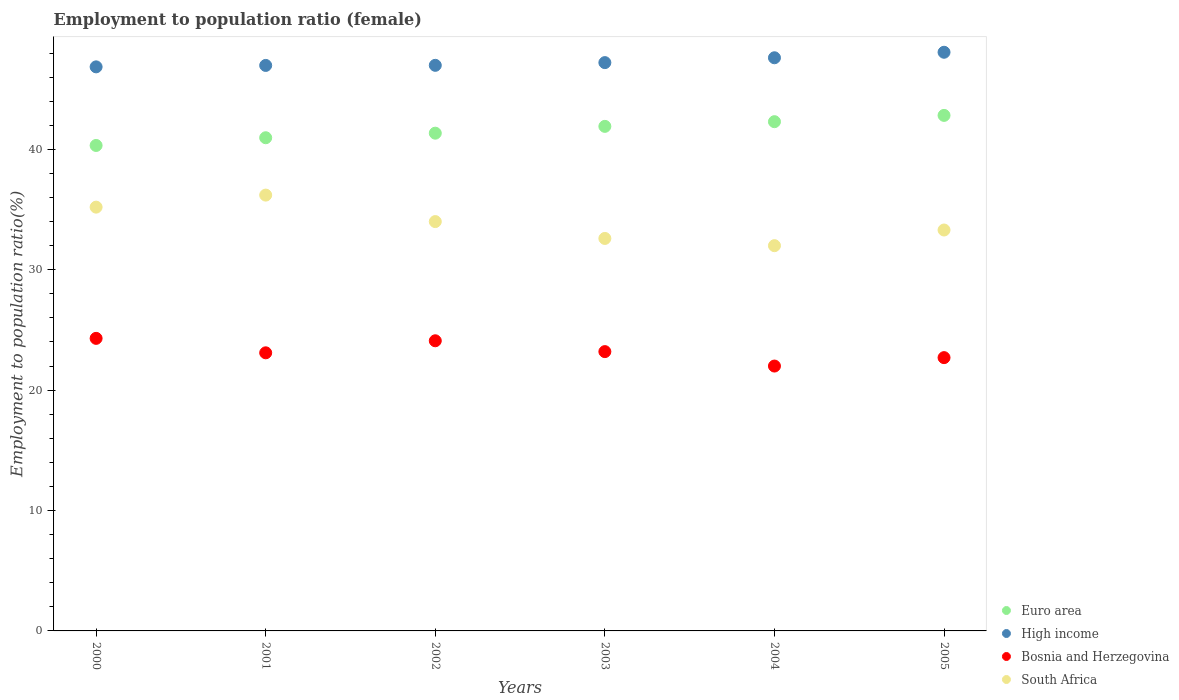What is the employment to population ratio in High income in 2005?
Provide a short and direct response. 48.06. Across all years, what is the maximum employment to population ratio in Bosnia and Herzegovina?
Keep it short and to the point. 24.3. In which year was the employment to population ratio in Euro area maximum?
Offer a very short reply. 2005. What is the total employment to population ratio in Euro area in the graph?
Give a very brief answer. 249.66. What is the difference between the employment to population ratio in Euro area in 2002 and that in 2003?
Keep it short and to the point. -0.57. What is the difference between the employment to population ratio in High income in 2004 and the employment to population ratio in South Africa in 2001?
Make the answer very short. 11.41. What is the average employment to population ratio in High income per year?
Your response must be concise. 47.28. In the year 2002, what is the difference between the employment to population ratio in South Africa and employment to population ratio in Bosnia and Herzegovina?
Give a very brief answer. 9.9. In how many years, is the employment to population ratio in Euro area greater than 4 %?
Provide a short and direct response. 6. What is the ratio of the employment to population ratio in High income in 2000 to that in 2003?
Offer a very short reply. 0.99. Is the employment to population ratio in High income in 2002 less than that in 2004?
Provide a short and direct response. Yes. What is the difference between the highest and the lowest employment to population ratio in Bosnia and Herzegovina?
Offer a terse response. 2.3. In how many years, is the employment to population ratio in High income greater than the average employment to population ratio in High income taken over all years?
Ensure brevity in your answer.  2. Is the sum of the employment to population ratio in South Africa in 2004 and 2005 greater than the maximum employment to population ratio in High income across all years?
Ensure brevity in your answer.  Yes. Is it the case that in every year, the sum of the employment to population ratio in Euro area and employment to population ratio in Bosnia and Herzegovina  is greater than the sum of employment to population ratio in South Africa and employment to population ratio in High income?
Your answer should be compact. Yes. Does the employment to population ratio in Euro area monotonically increase over the years?
Make the answer very short. Yes. Is the employment to population ratio in Euro area strictly greater than the employment to population ratio in South Africa over the years?
Give a very brief answer. Yes. Is the employment to population ratio in High income strictly less than the employment to population ratio in South Africa over the years?
Provide a short and direct response. No. Does the graph contain grids?
Provide a succinct answer. No. How many legend labels are there?
Provide a succinct answer. 4. What is the title of the graph?
Make the answer very short. Employment to population ratio (female). What is the label or title of the Y-axis?
Provide a short and direct response. Employment to population ratio(%). What is the Employment to population ratio(%) of Euro area in 2000?
Offer a terse response. 40.32. What is the Employment to population ratio(%) in High income in 2000?
Your answer should be very brief. 46.85. What is the Employment to population ratio(%) in Bosnia and Herzegovina in 2000?
Offer a very short reply. 24.3. What is the Employment to population ratio(%) in South Africa in 2000?
Provide a short and direct response. 35.2. What is the Employment to population ratio(%) of Euro area in 2001?
Provide a succinct answer. 40.96. What is the Employment to population ratio(%) in High income in 2001?
Make the answer very short. 46.97. What is the Employment to population ratio(%) in Bosnia and Herzegovina in 2001?
Make the answer very short. 23.1. What is the Employment to population ratio(%) of South Africa in 2001?
Give a very brief answer. 36.2. What is the Employment to population ratio(%) in Euro area in 2002?
Your answer should be very brief. 41.34. What is the Employment to population ratio(%) in High income in 2002?
Keep it short and to the point. 46.98. What is the Employment to population ratio(%) in Bosnia and Herzegovina in 2002?
Offer a very short reply. 24.1. What is the Employment to population ratio(%) in Euro area in 2003?
Keep it short and to the point. 41.91. What is the Employment to population ratio(%) in High income in 2003?
Keep it short and to the point. 47.2. What is the Employment to population ratio(%) in Bosnia and Herzegovina in 2003?
Your answer should be compact. 23.2. What is the Employment to population ratio(%) in South Africa in 2003?
Provide a succinct answer. 32.6. What is the Employment to population ratio(%) of Euro area in 2004?
Your answer should be very brief. 42.3. What is the Employment to population ratio(%) of High income in 2004?
Your response must be concise. 47.61. What is the Employment to population ratio(%) of South Africa in 2004?
Your answer should be compact. 32. What is the Employment to population ratio(%) of Euro area in 2005?
Make the answer very short. 42.82. What is the Employment to population ratio(%) of High income in 2005?
Offer a very short reply. 48.06. What is the Employment to population ratio(%) of Bosnia and Herzegovina in 2005?
Your answer should be compact. 22.7. What is the Employment to population ratio(%) of South Africa in 2005?
Keep it short and to the point. 33.3. Across all years, what is the maximum Employment to population ratio(%) of Euro area?
Make the answer very short. 42.82. Across all years, what is the maximum Employment to population ratio(%) in High income?
Your answer should be very brief. 48.06. Across all years, what is the maximum Employment to population ratio(%) in Bosnia and Herzegovina?
Provide a short and direct response. 24.3. Across all years, what is the maximum Employment to population ratio(%) in South Africa?
Ensure brevity in your answer.  36.2. Across all years, what is the minimum Employment to population ratio(%) of Euro area?
Your answer should be compact. 40.32. Across all years, what is the minimum Employment to population ratio(%) of High income?
Keep it short and to the point. 46.85. Across all years, what is the minimum Employment to population ratio(%) of Bosnia and Herzegovina?
Provide a succinct answer. 22. What is the total Employment to population ratio(%) in Euro area in the graph?
Offer a terse response. 249.66. What is the total Employment to population ratio(%) of High income in the graph?
Your answer should be very brief. 283.68. What is the total Employment to population ratio(%) in Bosnia and Herzegovina in the graph?
Provide a short and direct response. 139.4. What is the total Employment to population ratio(%) of South Africa in the graph?
Keep it short and to the point. 203.3. What is the difference between the Employment to population ratio(%) in Euro area in 2000 and that in 2001?
Provide a short and direct response. -0.64. What is the difference between the Employment to population ratio(%) in High income in 2000 and that in 2001?
Offer a very short reply. -0.12. What is the difference between the Employment to population ratio(%) in Bosnia and Herzegovina in 2000 and that in 2001?
Your response must be concise. 1.2. What is the difference between the Employment to population ratio(%) of South Africa in 2000 and that in 2001?
Your response must be concise. -1. What is the difference between the Employment to population ratio(%) in Euro area in 2000 and that in 2002?
Keep it short and to the point. -1.02. What is the difference between the Employment to population ratio(%) of High income in 2000 and that in 2002?
Keep it short and to the point. -0.13. What is the difference between the Employment to population ratio(%) in Bosnia and Herzegovina in 2000 and that in 2002?
Your response must be concise. 0.2. What is the difference between the Employment to population ratio(%) of Euro area in 2000 and that in 2003?
Keep it short and to the point. -1.59. What is the difference between the Employment to population ratio(%) in High income in 2000 and that in 2003?
Offer a terse response. -0.35. What is the difference between the Employment to population ratio(%) of South Africa in 2000 and that in 2003?
Your response must be concise. 2.6. What is the difference between the Employment to population ratio(%) of Euro area in 2000 and that in 2004?
Keep it short and to the point. -1.98. What is the difference between the Employment to population ratio(%) in High income in 2000 and that in 2004?
Ensure brevity in your answer.  -0.76. What is the difference between the Employment to population ratio(%) of Bosnia and Herzegovina in 2000 and that in 2004?
Offer a very short reply. 2.3. What is the difference between the Employment to population ratio(%) of Euro area in 2000 and that in 2005?
Keep it short and to the point. -2.5. What is the difference between the Employment to population ratio(%) in High income in 2000 and that in 2005?
Make the answer very short. -1.21. What is the difference between the Employment to population ratio(%) of South Africa in 2000 and that in 2005?
Give a very brief answer. 1.9. What is the difference between the Employment to population ratio(%) of Euro area in 2001 and that in 2002?
Offer a very short reply. -0.38. What is the difference between the Employment to population ratio(%) of High income in 2001 and that in 2002?
Your answer should be compact. -0.01. What is the difference between the Employment to population ratio(%) of South Africa in 2001 and that in 2002?
Your answer should be very brief. 2.2. What is the difference between the Employment to population ratio(%) in Euro area in 2001 and that in 2003?
Offer a very short reply. -0.94. What is the difference between the Employment to population ratio(%) of High income in 2001 and that in 2003?
Make the answer very short. -0.23. What is the difference between the Employment to population ratio(%) of Bosnia and Herzegovina in 2001 and that in 2003?
Provide a succinct answer. -0.1. What is the difference between the Employment to population ratio(%) in Euro area in 2001 and that in 2004?
Provide a succinct answer. -1.33. What is the difference between the Employment to population ratio(%) of High income in 2001 and that in 2004?
Offer a terse response. -0.64. What is the difference between the Employment to population ratio(%) in South Africa in 2001 and that in 2004?
Provide a succinct answer. 4.2. What is the difference between the Employment to population ratio(%) in Euro area in 2001 and that in 2005?
Your response must be concise. -1.86. What is the difference between the Employment to population ratio(%) in High income in 2001 and that in 2005?
Provide a short and direct response. -1.09. What is the difference between the Employment to population ratio(%) of Bosnia and Herzegovina in 2001 and that in 2005?
Your response must be concise. 0.4. What is the difference between the Employment to population ratio(%) of South Africa in 2001 and that in 2005?
Your answer should be compact. 2.9. What is the difference between the Employment to population ratio(%) in Euro area in 2002 and that in 2003?
Make the answer very short. -0.57. What is the difference between the Employment to population ratio(%) of High income in 2002 and that in 2003?
Make the answer very short. -0.23. What is the difference between the Employment to population ratio(%) of Bosnia and Herzegovina in 2002 and that in 2003?
Your answer should be compact. 0.9. What is the difference between the Employment to population ratio(%) in Euro area in 2002 and that in 2004?
Keep it short and to the point. -0.95. What is the difference between the Employment to population ratio(%) of High income in 2002 and that in 2004?
Your answer should be compact. -0.63. What is the difference between the Employment to population ratio(%) of Euro area in 2002 and that in 2005?
Give a very brief answer. -1.48. What is the difference between the Employment to population ratio(%) in High income in 2002 and that in 2005?
Keep it short and to the point. -1.09. What is the difference between the Employment to population ratio(%) of South Africa in 2002 and that in 2005?
Make the answer very short. 0.7. What is the difference between the Employment to population ratio(%) in Euro area in 2003 and that in 2004?
Ensure brevity in your answer.  -0.39. What is the difference between the Employment to population ratio(%) in High income in 2003 and that in 2004?
Ensure brevity in your answer.  -0.4. What is the difference between the Employment to population ratio(%) in South Africa in 2003 and that in 2004?
Make the answer very short. 0.6. What is the difference between the Employment to population ratio(%) of Euro area in 2003 and that in 2005?
Keep it short and to the point. -0.91. What is the difference between the Employment to population ratio(%) in High income in 2003 and that in 2005?
Your answer should be very brief. -0.86. What is the difference between the Employment to population ratio(%) in Bosnia and Herzegovina in 2003 and that in 2005?
Provide a succinct answer. 0.5. What is the difference between the Employment to population ratio(%) in Euro area in 2004 and that in 2005?
Offer a very short reply. -0.52. What is the difference between the Employment to population ratio(%) in High income in 2004 and that in 2005?
Your answer should be compact. -0.46. What is the difference between the Employment to population ratio(%) in Bosnia and Herzegovina in 2004 and that in 2005?
Keep it short and to the point. -0.7. What is the difference between the Employment to population ratio(%) of Euro area in 2000 and the Employment to population ratio(%) of High income in 2001?
Give a very brief answer. -6.65. What is the difference between the Employment to population ratio(%) in Euro area in 2000 and the Employment to population ratio(%) in Bosnia and Herzegovina in 2001?
Keep it short and to the point. 17.22. What is the difference between the Employment to population ratio(%) in Euro area in 2000 and the Employment to population ratio(%) in South Africa in 2001?
Your answer should be compact. 4.12. What is the difference between the Employment to population ratio(%) of High income in 2000 and the Employment to population ratio(%) of Bosnia and Herzegovina in 2001?
Your response must be concise. 23.75. What is the difference between the Employment to population ratio(%) of High income in 2000 and the Employment to population ratio(%) of South Africa in 2001?
Your answer should be compact. 10.65. What is the difference between the Employment to population ratio(%) of Bosnia and Herzegovina in 2000 and the Employment to population ratio(%) of South Africa in 2001?
Give a very brief answer. -11.9. What is the difference between the Employment to population ratio(%) of Euro area in 2000 and the Employment to population ratio(%) of High income in 2002?
Ensure brevity in your answer.  -6.66. What is the difference between the Employment to population ratio(%) of Euro area in 2000 and the Employment to population ratio(%) of Bosnia and Herzegovina in 2002?
Make the answer very short. 16.22. What is the difference between the Employment to population ratio(%) of Euro area in 2000 and the Employment to population ratio(%) of South Africa in 2002?
Give a very brief answer. 6.32. What is the difference between the Employment to population ratio(%) in High income in 2000 and the Employment to population ratio(%) in Bosnia and Herzegovina in 2002?
Ensure brevity in your answer.  22.75. What is the difference between the Employment to population ratio(%) of High income in 2000 and the Employment to population ratio(%) of South Africa in 2002?
Keep it short and to the point. 12.85. What is the difference between the Employment to population ratio(%) of Euro area in 2000 and the Employment to population ratio(%) of High income in 2003?
Offer a terse response. -6.88. What is the difference between the Employment to population ratio(%) in Euro area in 2000 and the Employment to population ratio(%) in Bosnia and Herzegovina in 2003?
Ensure brevity in your answer.  17.12. What is the difference between the Employment to population ratio(%) in Euro area in 2000 and the Employment to population ratio(%) in South Africa in 2003?
Provide a succinct answer. 7.72. What is the difference between the Employment to population ratio(%) in High income in 2000 and the Employment to population ratio(%) in Bosnia and Herzegovina in 2003?
Keep it short and to the point. 23.65. What is the difference between the Employment to population ratio(%) of High income in 2000 and the Employment to population ratio(%) of South Africa in 2003?
Offer a terse response. 14.25. What is the difference between the Employment to population ratio(%) of Bosnia and Herzegovina in 2000 and the Employment to population ratio(%) of South Africa in 2003?
Give a very brief answer. -8.3. What is the difference between the Employment to population ratio(%) in Euro area in 2000 and the Employment to population ratio(%) in High income in 2004?
Offer a terse response. -7.28. What is the difference between the Employment to population ratio(%) in Euro area in 2000 and the Employment to population ratio(%) in Bosnia and Herzegovina in 2004?
Offer a terse response. 18.32. What is the difference between the Employment to population ratio(%) in Euro area in 2000 and the Employment to population ratio(%) in South Africa in 2004?
Ensure brevity in your answer.  8.32. What is the difference between the Employment to population ratio(%) of High income in 2000 and the Employment to population ratio(%) of Bosnia and Herzegovina in 2004?
Provide a succinct answer. 24.85. What is the difference between the Employment to population ratio(%) of High income in 2000 and the Employment to population ratio(%) of South Africa in 2004?
Ensure brevity in your answer.  14.85. What is the difference between the Employment to population ratio(%) of Bosnia and Herzegovina in 2000 and the Employment to population ratio(%) of South Africa in 2004?
Your answer should be very brief. -7.7. What is the difference between the Employment to population ratio(%) of Euro area in 2000 and the Employment to population ratio(%) of High income in 2005?
Your response must be concise. -7.74. What is the difference between the Employment to population ratio(%) of Euro area in 2000 and the Employment to population ratio(%) of Bosnia and Herzegovina in 2005?
Offer a terse response. 17.62. What is the difference between the Employment to population ratio(%) of Euro area in 2000 and the Employment to population ratio(%) of South Africa in 2005?
Provide a short and direct response. 7.02. What is the difference between the Employment to population ratio(%) in High income in 2000 and the Employment to population ratio(%) in Bosnia and Herzegovina in 2005?
Your response must be concise. 24.15. What is the difference between the Employment to population ratio(%) in High income in 2000 and the Employment to population ratio(%) in South Africa in 2005?
Provide a succinct answer. 13.55. What is the difference between the Employment to population ratio(%) in Euro area in 2001 and the Employment to population ratio(%) in High income in 2002?
Offer a terse response. -6.01. What is the difference between the Employment to population ratio(%) in Euro area in 2001 and the Employment to population ratio(%) in Bosnia and Herzegovina in 2002?
Offer a very short reply. 16.86. What is the difference between the Employment to population ratio(%) of Euro area in 2001 and the Employment to population ratio(%) of South Africa in 2002?
Your answer should be compact. 6.96. What is the difference between the Employment to population ratio(%) in High income in 2001 and the Employment to population ratio(%) in Bosnia and Herzegovina in 2002?
Offer a very short reply. 22.87. What is the difference between the Employment to population ratio(%) in High income in 2001 and the Employment to population ratio(%) in South Africa in 2002?
Offer a very short reply. 12.97. What is the difference between the Employment to population ratio(%) of Euro area in 2001 and the Employment to population ratio(%) of High income in 2003?
Offer a terse response. -6.24. What is the difference between the Employment to population ratio(%) of Euro area in 2001 and the Employment to population ratio(%) of Bosnia and Herzegovina in 2003?
Keep it short and to the point. 17.76. What is the difference between the Employment to population ratio(%) in Euro area in 2001 and the Employment to population ratio(%) in South Africa in 2003?
Your answer should be compact. 8.36. What is the difference between the Employment to population ratio(%) of High income in 2001 and the Employment to population ratio(%) of Bosnia and Herzegovina in 2003?
Offer a terse response. 23.77. What is the difference between the Employment to population ratio(%) of High income in 2001 and the Employment to population ratio(%) of South Africa in 2003?
Give a very brief answer. 14.37. What is the difference between the Employment to population ratio(%) in Bosnia and Herzegovina in 2001 and the Employment to population ratio(%) in South Africa in 2003?
Ensure brevity in your answer.  -9.5. What is the difference between the Employment to population ratio(%) in Euro area in 2001 and the Employment to population ratio(%) in High income in 2004?
Offer a terse response. -6.64. What is the difference between the Employment to population ratio(%) in Euro area in 2001 and the Employment to population ratio(%) in Bosnia and Herzegovina in 2004?
Offer a very short reply. 18.96. What is the difference between the Employment to population ratio(%) in Euro area in 2001 and the Employment to population ratio(%) in South Africa in 2004?
Your response must be concise. 8.96. What is the difference between the Employment to population ratio(%) in High income in 2001 and the Employment to population ratio(%) in Bosnia and Herzegovina in 2004?
Your response must be concise. 24.97. What is the difference between the Employment to population ratio(%) in High income in 2001 and the Employment to population ratio(%) in South Africa in 2004?
Provide a succinct answer. 14.97. What is the difference between the Employment to population ratio(%) in Euro area in 2001 and the Employment to population ratio(%) in High income in 2005?
Provide a short and direct response. -7.1. What is the difference between the Employment to population ratio(%) in Euro area in 2001 and the Employment to population ratio(%) in Bosnia and Herzegovina in 2005?
Keep it short and to the point. 18.26. What is the difference between the Employment to population ratio(%) of Euro area in 2001 and the Employment to population ratio(%) of South Africa in 2005?
Ensure brevity in your answer.  7.66. What is the difference between the Employment to population ratio(%) in High income in 2001 and the Employment to population ratio(%) in Bosnia and Herzegovina in 2005?
Provide a succinct answer. 24.27. What is the difference between the Employment to population ratio(%) in High income in 2001 and the Employment to population ratio(%) in South Africa in 2005?
Give a very brief answer. 13.67. What is the difference between the Employment to population ratio(%) of Euro area in 2002 and the Employment to population ratio(%) of High income in 2003?
Give a very brief answer. -5.86. What is the difference between the Employment to population ratio(%) of Euro area in 2002 and the Employment to population ratio(%) of Bosnia and Herzegovina in 2003?
Offer a terse response. 18.14. What is the difference between the Employment to population ratio(%) in Euro area in 2002 and the Employment to population ratio(%) in South Africa in 2003?
Your answer should be very brief. 8.74. What is the difference between the Employment to population ratio(%) of High income in 2002 and the Employment to population ratio(%) of Bosnia and Herzegovina in 2003?
Your response must be concise. 23.78. What is the difference between the Employment to population ratio(%) of High income in 2002 and the Employment to population ratio(%) of South Africa in 2003?
Your response must be concise. 14.38. What is the difference between the Employment to population ratio(%) of Bosnia and Herzegovina in 2002 and the Employment to population ratio(%) of South Africa in 2003?
Your answer should be compact. -8.5. What is the difference between the Employment to population ratio(%) of Euro area in 2002 and the Employment to population ratio(%) of High income in 2004?
Your answer should be very brief. -6.26. What is the difference between the Employment to population ratio(%) in Euro area in 2002 and the Employment to population ratio(%) in Bosnia and Herzegovina in 2004?
Offer a very short reply. 19.34. What is the difference between the Employment to population ratio(%) of Euro area in 2002 and the Employment to population ratio(%) of South Africa in 2004?
Keep it short and to the point. 9.34. What is the difference between the Employment to population ratio(%) of High income in 2002 and the Employment to population ratio(%) of Bosnia and Herzegovina in 2004?
Your answer should be very brief. 24.98. What is the difference between the Employment to population ratio(%) of High income in 2002 and the Employment to population ratio(%) of South Africa in 2004?
Provide a short and direct response. 14.98. What is the difference between the Employment to population ratio(%) of Bosnia and Herzegovina in 2002 and the Employment to population ratio(%) of South Africa in 2004?
Your response must be concise. -7.9. What is the difference between the Employment to population ratio(%) in Euro area in 2002 and the Employment to population ratio(%) in High income in 2005?
Provide a short and direct response. -6.72. What is the difference between the Employment to population ratio(%) in Euro area in 2002 and the Employment to population ratio(%) in Bosnia and Herzegovina in 2005?
Offer a very short reply. 18.64. What is the difference between the Employment to population ratio(%) in Euro area in 2002 and the Employment to population ratio(%) in South Africa in 2005?
Your response must be concise. 8.04. What is the difference between the Employment to population ratio(%) of High income in 2002 and the Employment to population ratio(%) of Bosnia and Herzegovina in 2005?
Your answer should be very brief. 24.28. What is the difference between the Employment to population ratio(%) in High income in 2002 and the Employment to population ratio(%) in South Africa in 2005?
Ensure brevity in your answer.  13.68. What is the difference between the Employment to population ratio(%) in Bosnia and Herzegovina in 2002 and the Employment to population ratio(%) in South Africa in 2005?
Keep it short and to the point. -9.2. What is the difference between the Employment to population ratio(%) in Euro area in 2003 and the Employment to population ratio(%) in High income in 2004?
Provide a succinct answer. -5.7. What is the difference between the Employment to population ratio(%) of Euro area in 2003 and the Employment to population ratio(%) of Bosnia and Herzegovina in 2004?
Your answer should be compact. 19.91. What is the difference between the Employment to population ratio(%) in Euro area in 2003 and the Employment to population ratio(%) in South Africa in 2004?
Make the answer very short. 9.91. What is the difference between the Employment to population ratio(%) in High income in 2003 and the Employment to population ratio(%) in Bosnia and Herzegovina in 2004?
Your answer should be very brief. 25.2. What is the difference between the Employment to population ratio(%) in High income in 2003 and the Employment to population ratio(%) in South Africa in 2004?
Your response must be concise. 15.2. What is the difference between the Employment to population ratio(%) of Euro area in 2003 and the Employment to population ratio(%) of High income in 2005?
Your response must be concise. -6.16. What is the difference between the Employment to population ratio(%) of Euro area in 2003 and the Employment to population ratio(%) of Bosnia and Herzegovina in 2005?
Your answer should be very brief. 19.21. What is the difference between the Employment to population ratio(%) in Euro area in 2003 and the Employment to population ratio(%) in South Africa in 2005?
Make the answer very short. 8.61. What is the difference between the Employment to population ratio(%) in High income in 2003 and the Employment to population ratio(%) in Bosnia and Herzegovina in 2005?
Make the answer very short. 24.5. What is the difference between the Employment to population ratio(%) of High income in 2003 and the Employment to population ratio(%) of South Africa in 2005?
Offer a very short reply. 13.9. What is the difference between the Employment to population ratio(%) of Euro area in 2004 and the Employment to population ratio(%) of High income in 2005?
Provide a short and direct response. -5.77. What is the difference between the Employment to population ratio(%) in Euro area in 2004 and the Employment to population ratio(%) in Bosnia and Herzegovina in 2005?
Ensure brevity in your answer.  19.6. What is the difference between the Employment to population ratio(%) in Euro area in 2004 and the Employment to population ratio(%) in South Africa in 2005?
Make the answer very short. 9. What is the difference between the Employment to population ratio(%) of High income in 2004 and the Employment to population ratio(%) of Bosnia and Herzegovina in 2005?
Ensure brevity in your answer.  24.91. What is the difference between the Employment to population ratio(%) in High income in 2004 and the Employment to population ratio(%) in South Africa in 2005?
Ensure brevity in your answer.  14.31. What is the average Employment to population ratio(%) in Euro area per year?
Provide a short and direct response. 41.61. What is the average Employment to population ratio(%) of High income per year?
Your answer should be very brief. 47.28. What is the average Employment to population ratio(%) of Bosnia and Herzegovina per year?
Keep it short and to the point. 23.23. What is the average Employment to population ratio(%) of South Africa per year?
Offer a terse response. 33.88. In the year 2000, what is the difference between the Employment to population ratio(%) of Euro area and Employment to population ratio(%) of High income?
Keep it short and to the point. -6.53. In the year 2000, what is the difference between the Employment to population ratio(%) of Euro area and Employment to population ratio(%) of Bosnia and Herzegovina?
Give a very brief answer. 16.02. In the year 2000, what is the difference between the Employment to population ratio(%) of Euro area and Employment to population ratio(%) of South Africa?
Ensure brevity in your answer.  5.12. In the year 2000, what is the difference between the Employment to population ratio(%) in High income and Employment to population ratio(%) in Bosnia and Herzegovina?
Make the answer very short. 22.55. In the year 2000, what is the difference between the Employment to population ratio(%) of High income and Employment to population ratio(%) of South Africa?
Ensure brevity in your answer.  11.65. In the year 2001, what is the difference between the Employment to population ratio(%) of Euro area and Employment to population ratio(%) of High income?
Ensure brevity in your answer.  -6.01. In the year 2001, what is the difference between the Employment to population ratio(%) in Euro area and Employment to population ratio(%) in Bosnia and Herzegovina?
Keep it short and to the point. 17.86. In the year 2001, what is the difference between the Employment to population ratio(%) in Euro area and Employment to population ratio(%) in South Africa?
Your answer should be very brief. 4.76. In the year 2001, what is the difference between the Employment to population ratio(%) in High income and Employment to population ratio(%) in Bosnia and Herzegovina?
Your response must be concise. 23.87. In the year 2001, what is the difference between the Employment to population ratio(%) in High income and Employment to population ratio(%) in South Africa?
Your answer should be compact. 10.77. In the year 2001, what is the difference between the Employment to population ratio(%) of Bosnia and Herzegovina and Employment to population ratio(%) of South Africa?
Keep it short and to the point. -13.1. In the year 2002, what is the difference between the Employment to population ratio(%) of Euro area and Employment to population ratio(%) of High income?
Make the answer very short. -5.64. In the year 2002, what is the difference between the Employment to population ratio(%) of Euro area and Employment to population ratio(%) of Bosnia and Herzegovina?
Provide a short and direct response. 17.24. In the year 2002, what is the difference between the Employment to population ratio(%) of Euro area and Employment to population ratio(%) of South Africa?
Provide a succinct answer. 7.34. In the year 2002, what is the difference between the Employment to population ratio(%) in High income and Employment to population ratio(%) in Bosnia and Herzegovina?
Your response must be concise. 22.88. In the year 2002, what is the difference between the Employment to population ratio(%) of High income and Employment to population ratio(%) of South Africa?
Provide a succinct answer. 12.98. In the year 2003, what is the difference between the Employment to population ratio(%) of Euro area and Employment to population ratio(%) of High income?
Give a very brief answer. -5.3. In the year 2003, what is the difference between the Employment to population ratio(%) in Euro area and Employment to population ratio(%) in Bosnia and Herzegovina?
Your response must be concise. 18.71. In the year 2003, what is the difference between the Employment to population ratio(%) in Euro area and Employment to population ratio(%) in South Africa?
Offer a terse response. 9.31. In the year 2003, what is the difference between the Employment to population ratio(%) in High income and Employment to population ratio(%) in Bosnia and Herzegovina?
Your answer should be compact. 24. In the year 2003, what is the difference between the Employment to population ratio(%) in High income and Employment to population ratio(%) in South Africa?
Your answer should be very brief. 14.6. In the year 2004, what is the difference between the Employment to population ratio(%) in Euro area and Employment to population ratio(%) in High income?
Make the answer very short. -5.31. In the year 2004, what is the difference between the Employment to population ratio(%) of Euro area and Employment to population ratio(%) of Bosnia and Herzegovina?
Provide a short and direct response. 20.3. In the year 2004, what is the difference between the Employment to population ratio(%) of Euro area and Employment to population ratio(%) of South Africa?
Provide a short and direct response. 10.3. In the year 2004, what is the difference between the Employment to population ratio(%) of High income and Employment to population ratio(%) of Bosnia and Herzegovina?
Give a very brief answer. 25.61. In the year 2004, what is the difference between the Employment to population ratio(%) in High income and Employment to population ratio(%) in South Africa?
Offer a very short reply. 15.61. In the year 2004, what is the difference between the Employment to population ratio(%) in Bosnia and Herzegovina and Employment to population ratio(%) in South Africa?
Ensure brevity in your answer.  -10. In the year 2005, what is the difference between the Employment to population ratio(%) of Euro area and Employment to population ratio(%) of High income?
Your response must be concise. -5.24. In the year 2005, what is the difference between the Employment to population ratio(%) of Euro area and Employment to population ratio(%) of Bosnia and Herzegovina?
Provide a succinct answer. 20.12. In the year 2005, what is the difference between the Employment to population ratio(%) of Euro area and Employment to population ratio(%) of South Africa?
Your answer should be very brief. 9.52. In the year 2005, what is the difference between the Employment to population ratio(%) in High income and Employment to population ratio(%) in Bosnia and Herzegovina?
Make the answer very short. 25.36. In the year 2005, what is the difference between the Employment to population ratio(%) in High income and Employment to population ratio(%) in South Africa?
Keep it short and to the point. 14.76. What is the ratio of the Employment to population ratio(%) in Euro area in 2000 to that in 2001?
Offer a very short reply. 0.98. What is the ratio of the Employment to population ratio(%) of High income in 2000 to that in 2001?
Provide a succinct answer. 1. What is the ratio of the Employment to population ratio(%) of Bosnia and Herzegovina in 2000 to that in 2001?
Your response must be concise. 1.05. What is the ratio of the Employment to population ratio(%) of South Africa in 2000 to that in 2001?
Keep it short and to the point. 0.97. What is the ratio of the Employment to population ratio(%) in Euro area in 2000 to that in 2002?
Give a very brief answer. 0.98. What is the ratio of the Employment to population ratio(%) of High income in 2000 to that in 2002?
Keep it short and to the point. 1. What is the ratio of the Employment to population ratio(%) of Bosnia and Herzegovina in 2000 to that in 2002?
Provide a succinct answer. 1.01. What is the ratio of the Employment to population ratio(%) of South Africa in 2000 to that in 2002?
Offer a terse response. 1.04. What is the ratio of the Employment to population ratio(%) in Euro area in 2000 to that in 2003?
Make the answer very short. 0.96. What is the ratio of the Employment to population ratio(%) of Bosnia and Herzegovina in 2000 to that in 2003?
Keep it short and to the point. 1.05. What is the ratio of the Employment to population ratio(%) of South Africa in 2000 to that in 2003?
Your response must be concise. 1.08. What is the ratio of the Employment to population ratio(%) in Euro area in 2000 to that in 2004?
Provide a short and direct response. 0.95. What is the ratio of the Employment to population ratio(%) in High income in 2000 to that in 2004?
Give a very brief answer. 0.98. What is the ratio of the Employment to population ratio(%) of Bosnia and Herzegovina in 2000 to that in 2004?
Offer a very short reply. 1.1. What is the ratio of the Employment to population ratio(%) in South Africa in 2000 to that in 2004?
Offer a very short reply. 1.1. What is the ratio of the Employment to population ratio(%) in Euro area in 2000 to that in 2005?
Offer a terse response. 0.94. What is the ratio of the Employment to population ratio(%) of High income in 2000 to that in 2005?
Your response must be concise. 0.97. What is the ratio of the Employment to population ratio(%) in Bosnia and Herzegovina in 2000 to that in 2005?
Make the answer very short. 1.07. What is the ratio of the Employment to population ratio(%) of South Africa in 2000 to that in 2005?
Your answer should be compact. 1.06. What is the ratio of the Employment to population ratio(%) in High income in 2001 to that in 2002?
Give a very brief answer. 1. What is the ratio of the Employment to population ratio(%) in Bosnia and Herzegovina in 2001 to that in 2002?
Offer a very short reply. 0.96. What is the ratio of the Employment to population ratio(%) of South Africa in 2001 to that in 2002?
Provide a short and direct response. 1.06. What is the ratio of the Employment to population ratio(%) of Euro area in 2001 to that in 2003?
Offer a terse response. 0.98. What is the ratio of the Employment to population ratio(%) of Bosnia and Herzegovina in 2001 to that in 2003?
Your answer should be very brief. 1. What is the ratio of the Employment to population ratio(%) in South Africa in 2001 to that in 2003?
Keep it short and to the point. 1.11. What is the ratio of the Employment to population ratio(%) in Euro area in 2001 to that in 2004?
Provide a succinct answer. 0.97. What is the ratio of the Employment to population ratio(%) of High income in 2001 to that in 2004?
Offer a terse response. 0.99. What is the ratio of the Employment to population ratio(%) of South Africa in 2001 to that in 2004?
Your answer should be compact. 1.13. What is the ratio of the Employment to population ratio(%) in Euro area in 2001 to that in 2005?
Provide a short and direct response. 0.96. What is the ratio of the Employment to population ratio(%) in High income in 2001 to that in 2005?
Provide a short and direct response. 0.98. What is the ratio of the Employment to population ratio(%) of Bosnia and Herzegovina in 2001 to that in 2005?
Offer a very short reply. 1.02. What is the ratio of the Employment to population ratio(%) in South Africa in 2001 to that in 2005?
Your answer should be compact. 1.09. What is the ratio of the Employment to population ratio(%) in Euro area in 2002 to that in 2003?
Make the answer very short. 0.99. What is the ratio of the Employment to population ratio(%) in High income in 2002 to that in 2003?
Your answer should be compact. 1. What is the ratio of the Employment to population ratio(%) in Bosnia and Herzegovina in 2002 to that in 2003?
Your answer should be compact. 1.04. What is the ratio of the Employment to population ratio(%) of South Africa in 2002 to that in 2003?
Provide a succinct answer. 1.04. What is the ratio of the Employment to population ratio(%) of Euro area in 2002 to that in 2004?
Provide a succinct answer. 0.98. What is the ratio of the Employment to population ratio(%) in High income in 2002 to that in 2004?
Provide a short and direct response. 0.99. What is the ratio of the Employment to population ratio(%) of Bosnia and Herzegovina in 2002 to that in 2004?
Your answer should be compact. 1.1. What is the ratio of the Employment to population ratio(%) in Euro area in 2002 to that in 2005?
Make the answer very short. 0.97. What is the ratio of the Employment to population ratio(%) of High income in 2002 to that in 2005?
Give a very brief answer. 0.98. What is the ratio of the Employment to population ratio(%) in Bosnia and Herzegovina in 2002 to that in 2005?
Provide a succinct answer. 1.06. What is the ratio of the Employment to population ratio(%) in South Africa in 2002 to that in 2005?
Your answer should be very brief. 1.02. What is the ratio of the Employment to population ratio(%) of Euro area in 2003 to that in 2004?
Make the answer very short. 0.99. What is the ratio of the Employment to population ratio(%) of High income in 2003 to that in 2004?
Keep it short and to the point. 0.99. What is the ratio of the Employment to population ratio(%) in Bosnia and Herzegovina in 2003 to that in 2004?
Your response must be concise. 1.05. What is the ratio of the Employment to population ratio(%) of South Africa in 2003 to that in 2004?
Make the answer very short. 1.02. What is the ratio of the Employment to population ratio(%) of Euro area in 2003 to that in 2005?
Give a very brief answer. 0.98. What is the ratio of the Employment to population ratio(%) of High income in 2003 to that in 2005?
Keep it short and to the point. 0.98. What is the ratio of the Employment to population ratio(%) of Bosnia and Herzegovina in 2004 to that in 2005?
Your answer should be very brief. 0.97. What is the ratio of the Employment to population ratio(%) in South Africa in 2004 to that in 2005?
Your answer should be very brief. 0.96. What is the difference between the highest and the second highest Employment to population ratio(%) in Euro area?
Provide a short and direct response. 0.52. What is the difference between the highest and the second highest Employment to population ratio(%) in High income?
Your answer should be compact. 0.46. What is the difference between the highest and the second highest Employment to population ratio(%) of Bosnia and Herzegovina?
Offer a very short reply. 0.2. What is the difference between the highest and the lowest Employment to population ratio(%) of Euro area?
Keep it short and to the point. 2.5. What is the difference between the highest and the lowest Employment to population ratio(%) of High income?
Offer a very short reply. 1.21. What is the difference between the highest and the lowest Employment to population ratio(%) in Bosnia and Herzegovina?
Give a very brief answer. 2.3. 